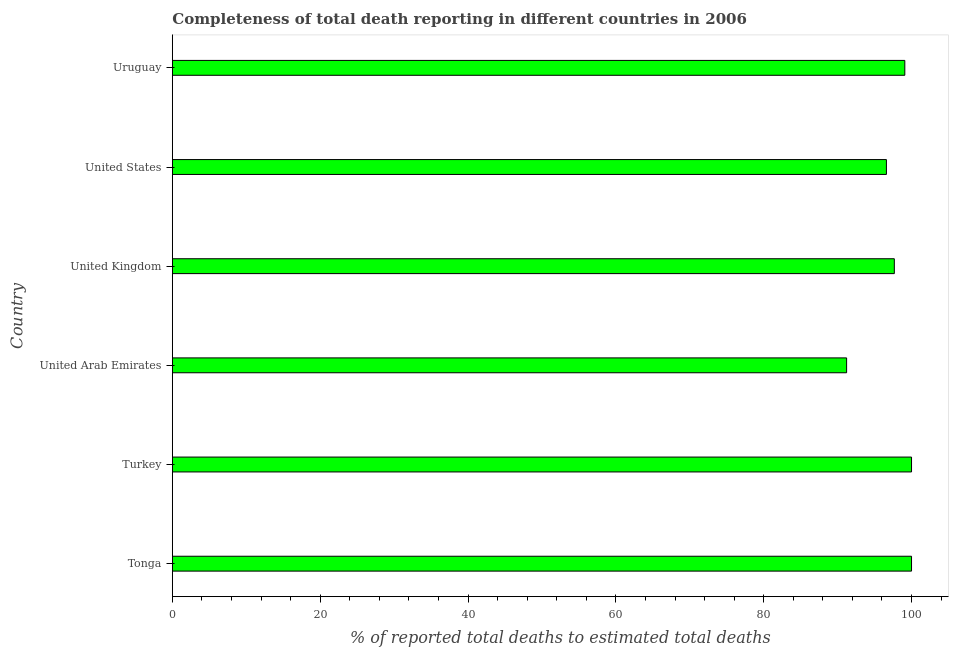Does the graph contain grids?
Keep it short and to the point. No. What is the title of the graph?
Offer a very short reply. Completeness of total death reporting in different countries in 2006. What is the label or title of the X-axis?
Provide a short and direct response. % of reported total deaths to estimated total deaths. What is the label or title of the Y-axis?
Offer a very short reply. Country. What is the completeness of total death reports in United Arab Emirates?
Your answer should be very brief. 91.22. Across all countries, what is the minimum completeness of total death reports?
Your answer should be compact. 91.22. In which country was the completeness of total death reports maximum?
Your answer should be very brief. Tonga. In which country was the completeness of total death reports minimum?
Give a very brief answer. United Arab Emirates. What is the sum of the completeness of total death reports?
Keep it short and to the point. 584.58. What is the difference between the completeness of total death reports in Tonga and Uruguay?
Make the answer very short. 0.91. What is the average completeness of total death reports per country?
Your answer should be very brief. 97.43. What is the median completeness of total death reports?
Keep it short and to the point. 98.38. Is the difference between the completeness of total death reports in United Arab Emirates and Uruguay greater than the difference between any two countries?
Ensure brevity in your answer.  No. What is the difference between the highest and the second highest completeness of total death reports?
Your response must be concise. 0. What is the difference between the highest and the lowest completeness of total death reports?
Your answer should be very brief. 8.78. In how many countries, is the completeness of total death reports greater than the average completeness of total death reports taken over all countries?
Your answer should be very brief. 4. What is the difference between two consecutive major ticks on the X-axis?
Your answer should be compact. 20. Are the values on the major ticks of X-axis written in scientific E-notation?
Your response must be concise. No. What is the % of reported total deaths to estimated total deaths of Tonga?
Provide a short and direct response. 100. What is the % of reported total deaths to estimated total deaths in Turkey?
Provide a succinct answer. 100. What is the % of reported total deaths to estimated total deaths in United Arab Emirates?
Your answer should be very brief. 91.22. What is the % of reported total deaths to estimated total deaths of United Kingdom?
Your response must be concise. 97.67. What is the % of reported total deaths to estimated total deaths in United States?
Offer a terse response. 96.6. What is the % of reported total deaths to estimated total deaths of Uruguay?
Your answer should be compact. 99.09. What is the difference between the % of reported total deaths to estimated total deaths in Tonga and United Arab Emirates?
Offer a terse response. 8.78. What is the difference between the % of reported total deaths to estimated total deaths in Tonga and United Kingdom?
Keep it short and to the point. 2.33. What is the difference between the % of reported total deaths to estimated total deaths in Tonga and United States?
Keep it short and to the point. 3.4. What is the difference between the % of reported total deaths to estimated total deaths in Tonga and Uruguay?
Provide a short and direct response. 0.91. What is the difference between the % of reported total deaths to estimated total deaths in Turkey and United Arab Emirates?
Make the answer very short. 8.78. What is the difference between the % of reported total deaths to estimated total deaths in Turkey and United Kingdom?
Your response must be concise. 2.33. What is the difference between the % of reported total deaths to estimated total deaths in Turkey and United States?
Offer a terse response. 3.4. What is the difference between the % of reported total deaths to estimated total deaths in Turkey and Uruguay?
Make the answer very short. 0.91. What is the difference between the % of reported total deaths to estimated total deaths in United Arab Emirates and United Kingdom?
Give a very brief answer. -6.46. What is the difference between the % of reported total deaths to estimated total deaths in United Arab Emirates and United States?
Your answer should be compact. -5.39. What is the difference between the % of reported total deaths to estimated total deaths in United Arab Emirates and Uruguay?
Offer a very short reply. -7.87. What is the difference between the % of reported total deaths to estimated total deaths in United Kingdom and United States?
Your answer should be very brief. 1.07. What is the difference between the % of reported total deaths to estimated total deaths in United Kingdom and Uruguay?
Ensure brevity in your answer.  -1.42. What is the difference between the % of reported total deaths to estimated total deaths in United States and Uruguay?
Your answer should be very brief. -2.49. What is the ratio of the % of reported total deaths to estimated total deaths in Tonga to that in Turkey?
Your answer should be very brief. 1. What is the ratio of the % of reported total deaths to estimated total deaths in Tonga to that in United Arab Emirates?
Ensure brevity in your answer.  1.1. What is the ratio of the % of reported total deaths to estimated total deaths in Tonga to that in United Kingdom?
Give a very brief answer. 1.02. What is the ratio of the % of reported total deaths to estimated total deaths in Tonga to that in United States?
Your answer should be compact. 1.03. What is the ratio of the % of reported total deaths to estimated total deaths in Tonga to that in Uruguay?
Ensure brevity in your answer.  1.01. What is the ratio of the % of reported total deaths to estimated total deaths in Turkey to that in United Arab Emirates?
Offer a very short reply. 1.1. What is the ratio of the % of reported total deaths to estimated total deaths in Turkey to that in United Kingdom?
Offer a terse response. 1.02. What is the ratio of the % of reported total deaths to estimated total deaths in Turkey to that in United States?
Give a very brief answer. 1.03. What is the ratio of the % of reported total deaths to estimated total deaths in United Arab Emirates to that in United Kingdom?
Provide a short and direct response. 0.93. What is the ratio of the % of reported total deaths to estimated total deaths in United Arab Emirates to that in United States?
Provide a succinct answer. 0.94. What is the ratio of the % of reported total deaths to estimated total deaths in United Arab Emirates to that in Uruguay?
Ensure brevity in your answer.  0.92. What is the ratio of the % of reported total deaths to estimated total deaths in United Kingdom to that in United States?
Offer a very short reply. 1.01. What is the ratio of the % of reported total deaths to estimated total deaths in United States to that in Uruguay?
Keep it short and to the point. 0.97. 